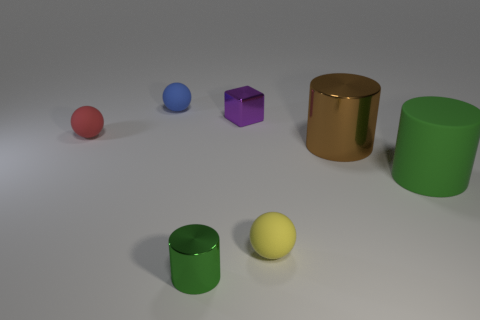What is the size of the metallic cylinder that is the same color as the large rubber thing?
Offer a very short reply. Small. There is a small shiny object that is behind the object that is to the right of the brown cylinder; is there a tiny purple block right of it?
Provide a short and direct response. No. There is a blue thing; are there any objects right of it?
Provide a succinct answer. Yes. There is a green object that is to the right of the tiny yellow thing; what number of small rubber spheres are behind it?
Your response must be concise. 2. Is the size of the rubber cylinder the same as the matte ball that is in front of the small red matte sphere?
Your response must be concise. No. Is there a large metallic object that has the same color as the small cylinder?
Your response must be concise. No. What is the size of the green cylinder that is the same material as the tiny purple thing?
Your answer should be very brief. Small. Do the purple block and the brown thing have the same material?
Offer a terse response. Yes. What is the color of the metallic cylinder to the left of the tiny yellow rubber thing that is in front of the small shiny thing that is behind the small red matte object?
Your response must be concise. Green. The brown object has what shape?
Your answer should be very brief. Cylinder. 